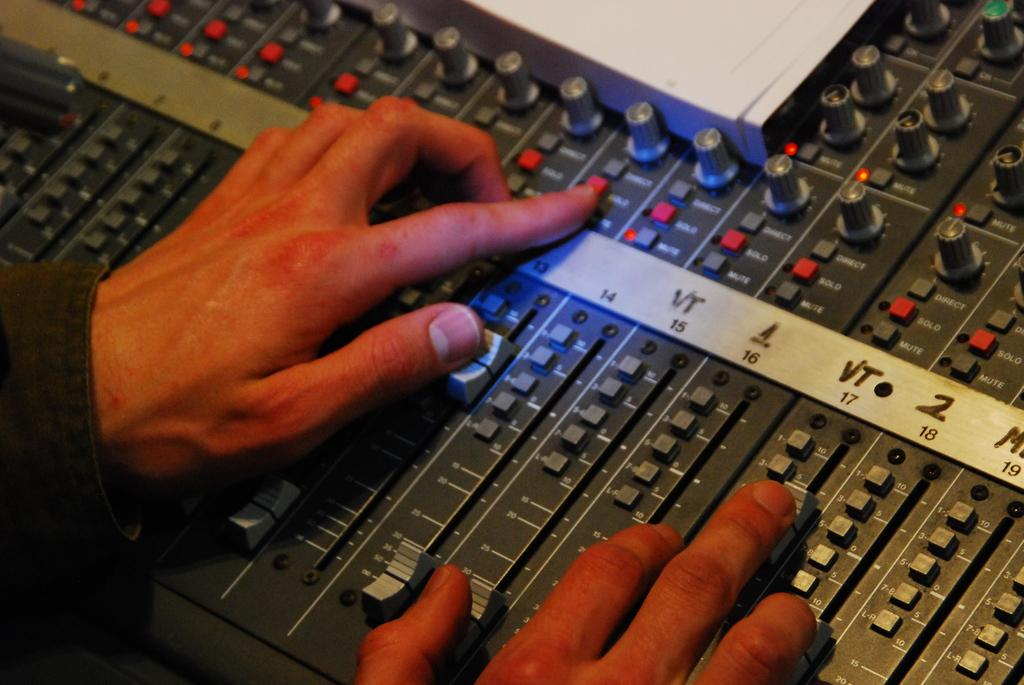<image>
Offer a succinct explanation of the picture presented. A person adjusts a control under the VT 17 section. 